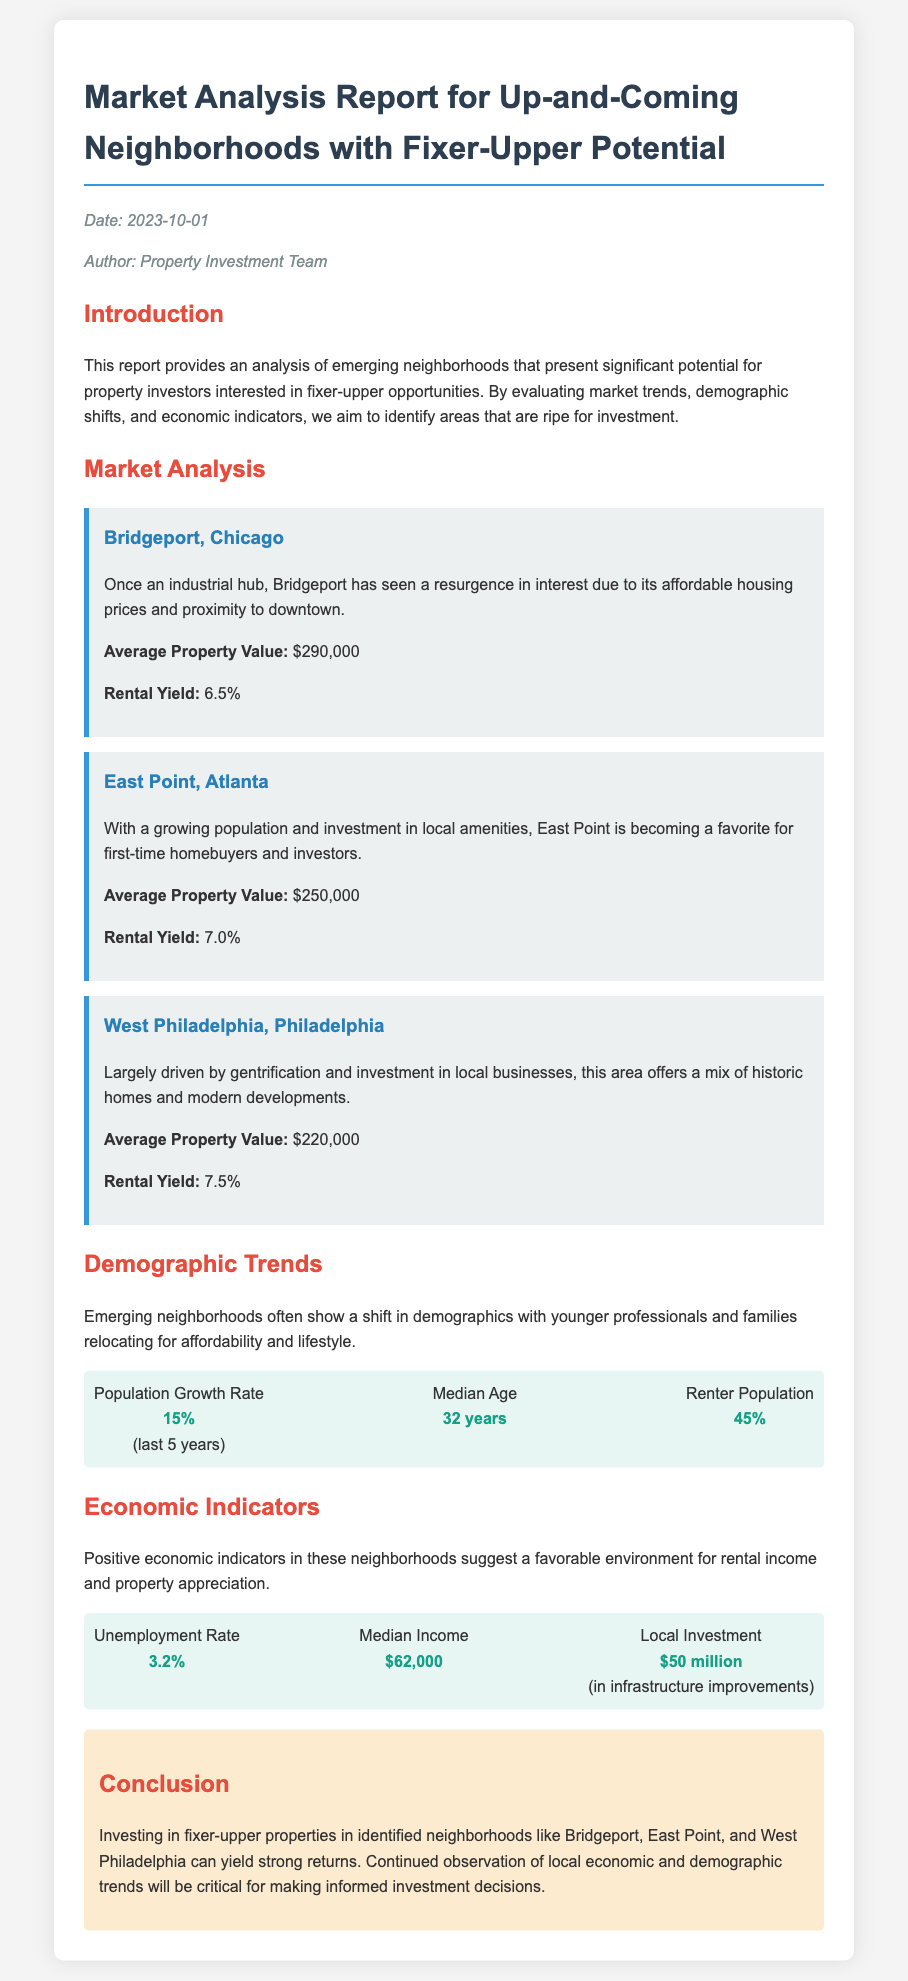what is the date of the report? The date of the report is mentioned in the meta section of the document.
Answer: 2023-10-01 who authored the memo? The author of the memo is listed in the meta section.
Answer: Property Investment Team what is the average property value in Bridgeport? The average property value for Bridgeport is provided in the market analysis section.
Answer: $290,000 what is the rental yield for West Philadelphia? The rental yield for West Philadelphia is mentioned under the respective neighborhood section.
Answer: 7.5% what is the local investment amount mentioned in the economic indicators? The local investment amount is detailed in the economic indicators section of the document.
Answer: $50 million what is the median age of the population in these neighborhoods? The median age is listed under the demographic trends section.
Answer: 32 years which neighborhood has the highest rental yield? The rental yields for each neighborhood are compared in the market analysis section.
Answer: West Philadelphia what percentage of the population are renters? The percentage of renters is provided in the demographic trends statistics.
Answer: 45% what is the unemployment rate in the neighborhoods studied? The unemployment rate is found in the economic indicators section.
Answer: 3.2% 